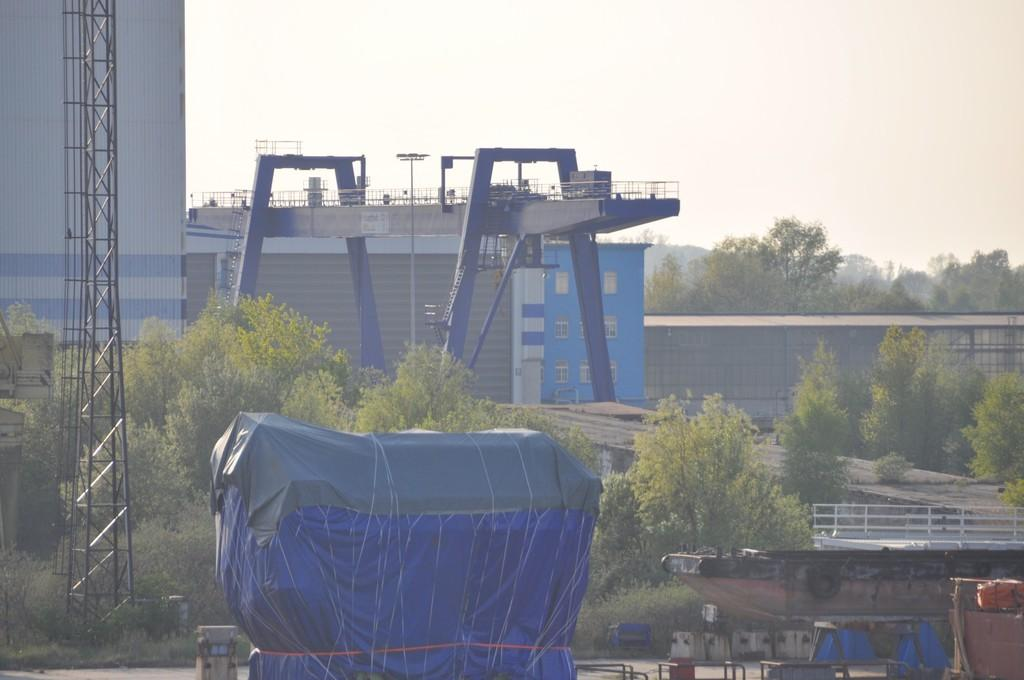What type of structures can be seen in the image? There are buildings in the image. What else can be seen in the image besides buildings? There are poles, trees, and some objects in the image. What is visible in the background of the image? The sky is visible in the background of the image. What statement does the lead make in the image? There is no lead or statement present in the image. What is located at the back of the image? The provided facts do not specify any particular location or object at the back of the image. 